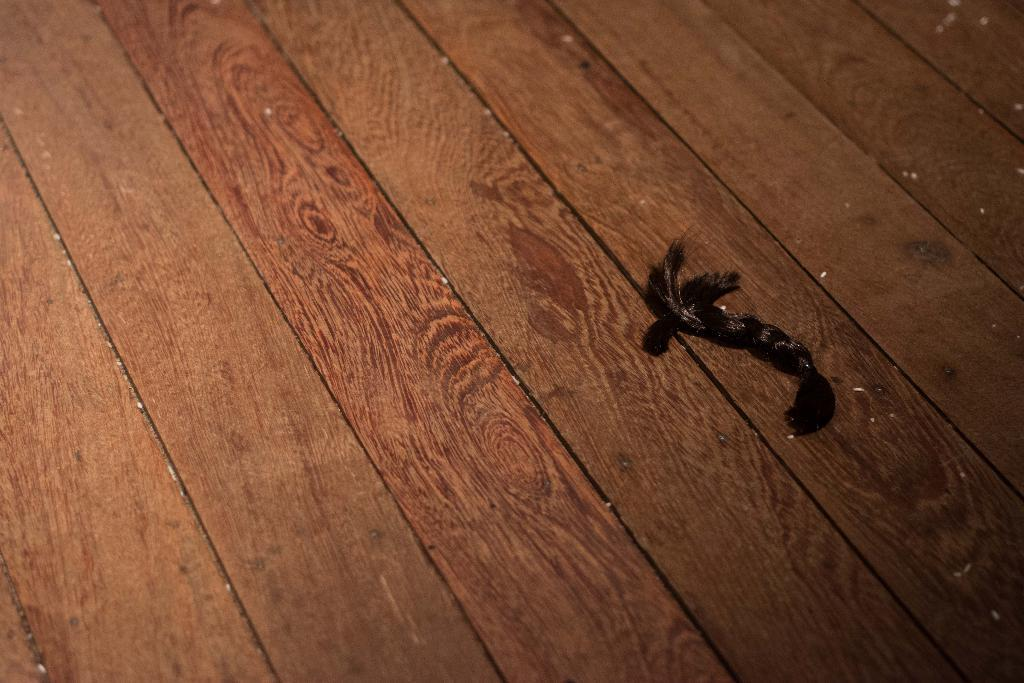What animal is present in the image? There is a deer in the image. What is the deer doing in the image? The deer is flying in the image. Where is the deer located in the image? The deer is on a table in the image. What type of tomatoes can be seen growing on the coast in the image? There are no tomatoes or coast present in the image; it features a flying deer on a table. 